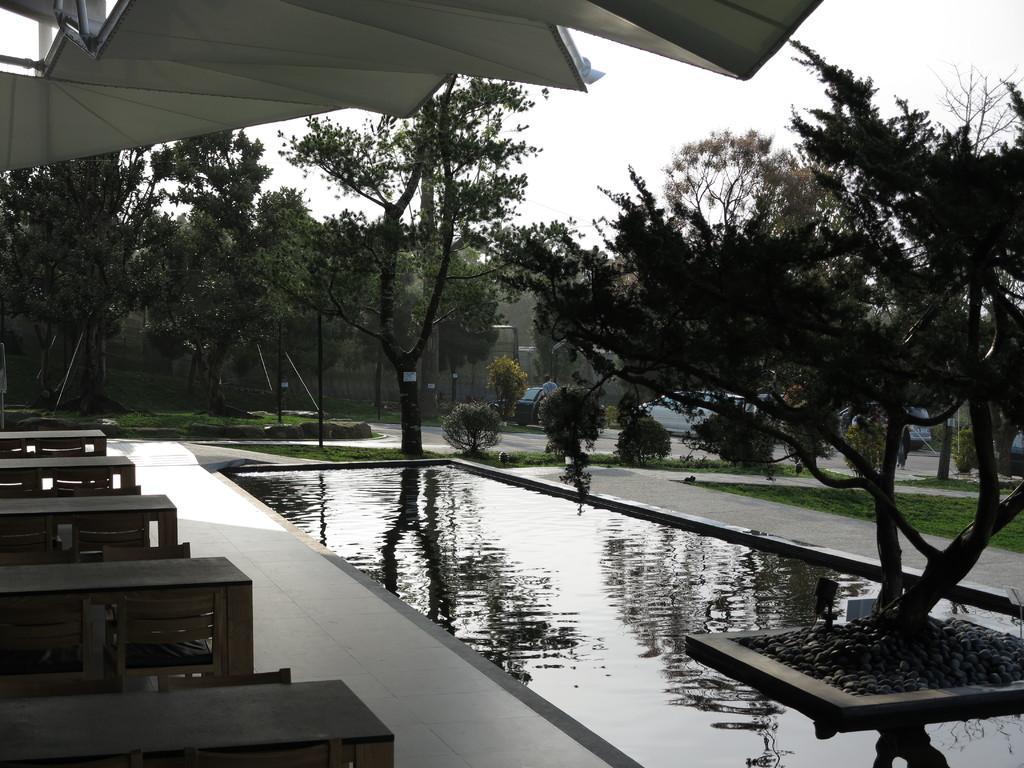Please provide a concise description of this image. This picture shows water and few trees, few tables and chairs and we see grass on the ground and few cars parked and a man standing and we see a cloudy sky. 